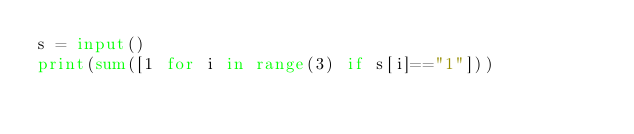Convert code to text. <code><loc_0><loc_0><loc_500><loc_500><_Python_>s = input()
print(sum([1 for i in range(3) if s[i]=="1"]))
</code> 